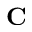Convert formula to latex. <formula><loc_0><loc_0><loc_500><loc_500>C</formula> 